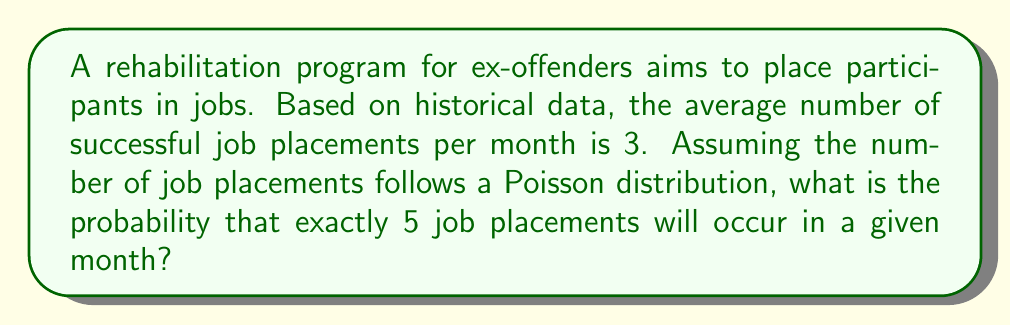Help me with this question. To solve this problem, we'll use the Poisson distribution formula:

$$P(X = k) = \frac{e^{-\lambda} \lambda^k}{k!}$$

Where:
$\lambda$ = average number of events in the given time interval
$k$ = number of events we're calculating the probability for
$e$ = Euler's number (approximately 2.71828)

Given:
$\lambda = 3$ (average number of job placements per month)
$k = 5$ (number of job placements we're calculating the probability for)

Step 1: Substitute the values into the formula:

$$P(X = 5) = \frac{e^{-3} 3^5}{5!}$$

Step 2: Calculate $3^5$:
$3^5 = 243$

Step 3: Calculate $5!$:
$5! = 5 \times 4 \times 3 \times 2 \times 1 = 120$

Step 4: Calculate $e^{-3}$:
$e^{-3} \approx 0.0497870684$

Step 5: Put it all together:

$$P(X = 5) = \frac{0.0497870684 \times 243}{120}$$

Step 6: Perform the final calculation:
$P(X = 5) \approx 0.1008$

This means there is approximately a 10.08% chance of exactly 5 job placements occurring in a given month.
Answer: $0.1008$ or $10.08\%$ 